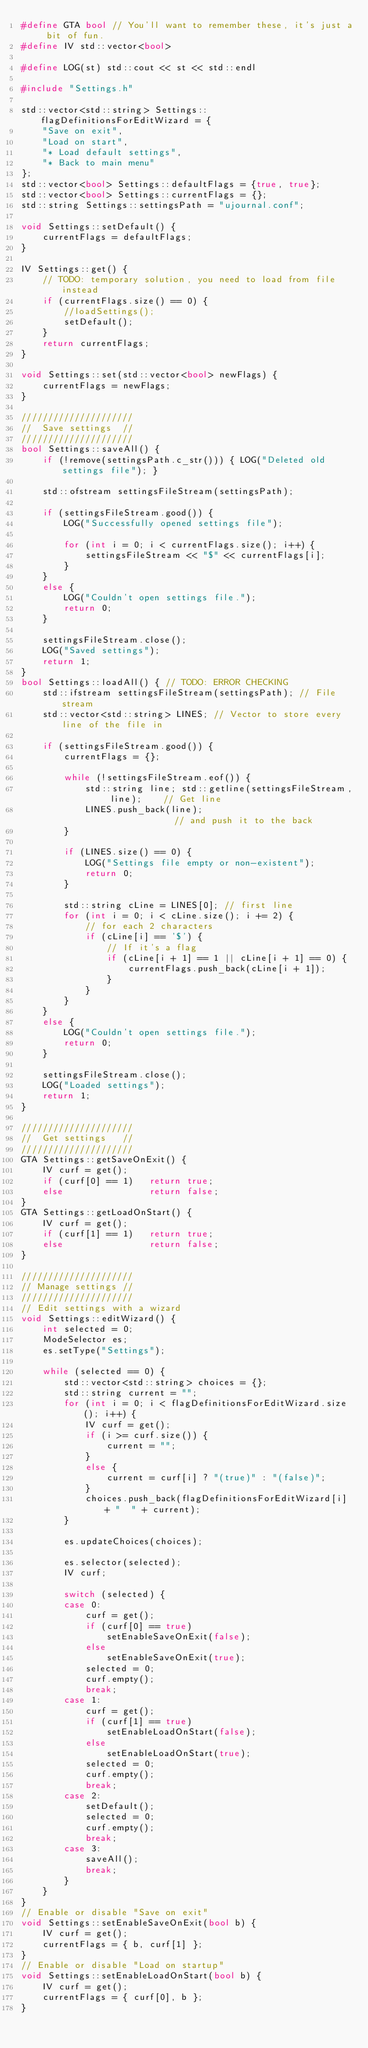Convert code to text. <code><loc_0><loc_0><loc_500><loc_500><_C++_>#define GTA bool // You'll want to remember these, it's just a bit of fun.
#define IV std::vector<bool>

#define LOG(st) std::cout << st << std::endl

#include "Settings.h"

std::vector<std::string> Settings::flagDefinitionsForEditWizard = {
	"Save on exit",
	"Load on start",
	"* Load default settings",
	"* Back to main menu"
};
std::vector<bool> Settings::defaultFlags = {true, true};
std::vector<bool> Settings::currentFlags = {};
std::string Settings::settingsPath = "ujournal.conf";

void Settings::setDefault() {
	currentFlags = defaultFlags;
}

IV Settings::get() {
	// TODO: temporary solution, you need to load from file instead
	if (currentFlags.size() == 0) {
		//loadSettings();
		setDefault();
	}
	return currentFlags;
}

void Settings::set(std::vector<bool> newFlags) {
	currentFlags = newFlags;
}

/////////////////////
//  Save settings  //
/////////////////////
bool Settings::saveAll() {
	if (!remove(settingsPath.c_str())) { LOG("Deleted old settings file"); }

	std::ofstream settingsFileStream(settingsPath);

	if (settingsFileStream.good()) {
		LOG("Successfully opened settings file");

		for (int i = 0; i < currentFlags.size(); i++) {
			settingsFileStream << "$" << currentFlags[i];
		}
	}
	else {
		LOG("Couldn't open settings file.");
		return 0;
	}

	settingsFileStream.close();
	LOG("Saved settings");
	return 1;
}
bool Settings::loadAll() { // TODO: ERROR CHECKING
	std::ifstream settingsFileStream(settingsPath); // File stream
	std::vector<std::string> LINES; // Vector to store every line of the file in

	if (settingsFileStream.good()) {
		currentFlags = {};

		while (!settingsFileStream.eof()) {
			std::string line; std::getline(settingsFileStream, line);	 // Get line
			LINES.push_back(line);										 // and push it to the back
		}

		if (LINES.size() == 0) {
			LOG("Settings file empty or non-existent");
			return 0;
		}

		std::string cLine = LINES[0]; // first line
		for (int i = 0; i < cLine.size(); i += 2) {
			// for each 2 characters
			if (cLine[i] == '$') {
				// If it's a flag
				if (cLine[i + 1] == 1 || cLine[i + 1] == 0) {
					currentFlags.push_back(cLine[i + 1]);
				}
			}
		}
	}
	else {
		LOG("Couldn't open settings file.");
		return 0;
	}

	settingsFileStream.close();
	LOG("Loaded settings");
	return 1;
}

/////////////////////
//  Get settings   //
/////////////////////
GTA Settings::getSaveOnExit() {
	IV curf = get();
	if (curf[0] == 1)	return true;
	else				return false;
}
GTA Settings::getLoadOnStart() {
	IV curf = get();
	if (curf[1] == 1)	return true;
	else				return false;
}

/////////////////////
// Manage settings //
/////////////////////
// Edit settings with a wizard
void Settings::editWizard() {
	int selected = 0;
	ModeSelector es;
	es.setType("Settings");

	while (selected == 0) {
		std::vector<std::string> choices = {};
		std::string current = "";
		for (int i = 0; i < flagDefinitionsForEditWizard.size(); i++) {
			IV curf = get();
			if (i >= curf.size()) {
				current = "";
			}
			else {
				current = curf[i] ? "(true)" : "(false)";
			}
			choices.push_back(flagDefinitionsForEditWizard[i] + "  " + current);
		}

		es.updateChoices(choices);

		es.selector(selected);
		IV curf;

		switch (selected) {
		case 0:
			curf = get();
			if (curf[0] == true)
				setEnableSaveOnExit(false);
			else
				setEnableSaveOnExit(true);
			selected = 0;
			curf.empty();
			break;
		case 1:
			curf = get();
			if (curf[1] == true)
				setEnableLoadOnStart(false);
			else
				setEnableLoadOnStart(true);
			selected = 0;
			curf.empty();
			break;
		case 2:
			setDefault();
			selected = 0;
			curf.empty();
			break;
		case 3:
			saveAll();
			break;
		}
	}
}
// Enable or disable "Save on exit"
void Settings::setEnableSaveOnExit(bool b) {
	IV curf = get();
	currentFlags = { b, curf[1] };
}
// Enable or disable "Load on startup"
void Settings::setEnableLoadOnStart(bool b) {
	IV curf = get();
	currentFlags = { curf[0], b };
}</code> 